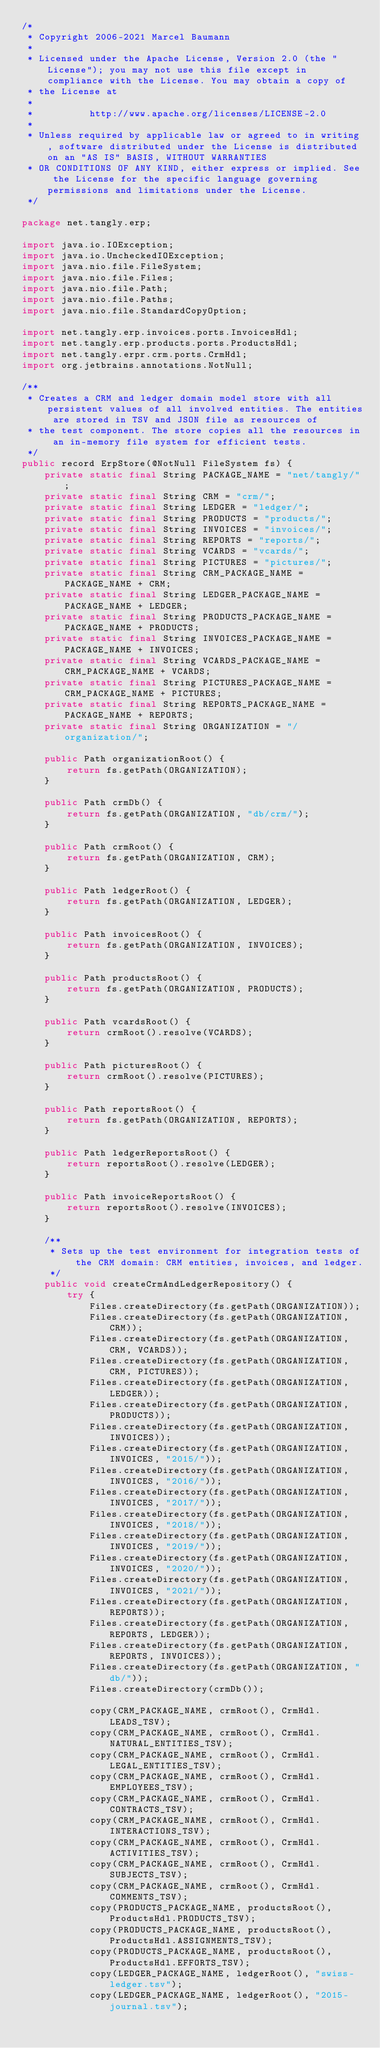<code> <loc_0><loc_0><loc_500><loc_500><_Java_>/*
 * Copyright 2006-2021 Marcel Baumann
 *
 * Licensed under the Apache License, Version 2.0 (the "License"); you may not use this file except in compliance with the License. You may obtain a copy of
 * the License at
 *
 *          http://www.apache.org/licenses/LICENSE-2.0
 *
 * Unless required by applicable law or agreed to in writing, software distributed under the License is distributed on an "AS IS" BASIS, WITHOUT WARRANTIES
 * OR CONDITIONS OF ANY KIND, either express or implied. See the License for the specific language governing permissions and limitations under the License.
 */

package net.tangly.erp;

import java.io.IOException;
import java.io.UncheckedIOException;
import java.nio.file.FileSystem;
import java.nio.file.Files;
import java.nio.file.Path;
import java.nio.file.Paths;
import java.nio.file.StandardCopyOption;

import net.tangly.erp.invoices.ports.InvoicesHdl;
import net.tangly.erp.products.ports.ProductsHdl;
import net.tangly.erpr.crm.ports.CrmHdl;
import org.jetbrains.annotations.NotNull;

/**
 * Creates a CRM and ledger domain model store with all persistent values of all involved entities. The entities are stored in TSV and JSON file as resources of
 * the test component. The store copies all the resources in an in-memory file system for efficient tests.
 */
public record ErpStore(@NotNull FileSystem fs) {
    private static final String PACKAGE_NAME = "net/tangly/";
    private static final String CRM = "crm/";
    private static final String LEDGER = "ledger/";
    private static final String PRODUCTS = "products/";
    private static final String INVOICES = "invoices/";
    private static final String REPORTS = "reports/";
    private static final String VCARDS = "vcards/";
    private static final String PICTURES = "pictures/";
    private static final String CRM_PACKAGE_NAME = PACKAGE_NAME + CRM;
    private static final String LEDGER_PACKAGE_NAME = PACKAGE_NAME + LEDGER;
    private static final String PRODUCTS_PACKAGE_NAME = PACKAGE_NAME + PRODUCTS;
    private static final String INVOICES_PACKAGE_NAME = PACKAGE_NAME + INVOICES;
    private static final String VCARDS_PACKAGE_NAME = CRM_PACKAGE_NAME + VCARDS;
    private static final String PICTURES_PACKAGE_NAME = CRM_PACKAGE_NAME + PICTURES;
    private static final String REPORTS_PACKAGE_NAME = PACKAGE_NAME + REPORTS;
    private static final String ORGANIZATION = "/organization/";

    public Path organizationRoot() {
        return fs.getPath(ORGANIZATION);
    }

    public Path crmDb() {
        return fs.getPath(ORGANIZATION, "db/crm/");
    }

    public Path crmRoot() {
        return fs.getPath(ORGANIZATION, CRM);
    }

    public Path ledgerRoot() {
        return fs.getPath(ORGANIZATION, LEDGER);
    }

    public Path invoicesRoot() {
        return fs.getPath(ORGANIZATION, INVOICES);
    }

    public Path productsRoot() {
        return fs.getPath(ORGANIZATION, PRODUCTS);
    }

    public Path vcardsRoot() {
        return crmRoot().resolve(VCARDS);
    }

    public Path picturesRoot() {
        return crmRoot().resolve(PICTURES);
    }

    public Path reportsRoot() {
        return fs.getPath(ORGANIZATION, REPORTS);
    }

    public Path ledgerReportsRoot() {
        return reportsRoot().resolve(LEDGER);
    }

    public Path invoiceReportsRoot() {
        return reportsRoot().resolve(INVOICES);
    }

    /**
     * Sets up the test environment for integration tests of the CRM domain: CRM entities, invoices, and ledger.
     */
    public void createCrmAndLedgerRepository() {
        try {
            Files.createDirectory(fs.getPath(ORGANIZATION));
            Files.createDirectory(fs.getPath(ORGANIZATION, CRM));
            Files.createDirectory(fs.getPath(ORGANIZATION, CRM, VCARDS));
            Files.createDirectory(fs.getPath(ORGANIZATION, CRM, PICTURES));
            Files.createDirectory(fs.getPath(ORGANIZATION, LEDGER));
            Files.createDirectory(fs.getPath(ORGANIZATION, PRODUCTS));
            Files.createDirectory(fs.getPath(ORGANIZATION, INVOICES));
            Files.createDirectory(fs.getPath(ORGANIZATION, INVOICES, "2015/"));
            Files.createDirectory(fs.getPath(ORGANIZATION, INVOICES, "2016/"));
            Files.createDirectory(fs.getPath(ORGANIZATION, INVOICES, "2017/"));
            Files.createDirectory(fs.getPath(ORGANIZATION, INVOICES, "2018/"));
            Files.createDirectory(fs.getPath(ORGANIZATION, INVOICES, "2019/"));
            Files.createDirectory(fs.getPath(ORGANIZATION, INVOICES, "2020/"));
            Files.createDirectory(fs.getPath(ORGANIZATION, INVOICES, "2021/"));
            Files.createDirectory(fs.getPath(ORGANIZATION, REPORTS));
            Files.createDirectory(fs.getPath(ORGANIZATION, REPORTS, LEDGER));
            Files.createDirectory(fs.getPath(ORGANIZATION, REPORTS, INVOICES));
            Files.createDirectory(fs.getPath(ORGANIZATION, "db/"));
            Files.createDirectory(crmDb());

            copy(CRM_PACKAGE_NAME, crmRoot(), CrmHdl.LEADS_TSV);
            copy(CRM_PACKAGE_NAME, crmRoot(), CrmHdl.NATURAL_ENTITIES_TSV);
            copy(CRM_PACKAGE_NAME, crmRoot(), CrmHdl.LEGAL_ENTITIES_TSV);
            copy(CRM_PACKAGE_NAME, crmRoot(), CrmHdl.EMPLOYEES_TSV);
            copy(CRM_PACKAGE_NAME, crmRoot(), CrmHdl.CONTRACTS_TSV);
            copy(CRM_PACKAGE_NAME, crmRoot(), CrmHdl.INTERACTIONS_TSV);
            copy(CRM_PACKAGE_NAME, crmRoot(), CrmHdl.ACTIVITIES_TSV);
            copy(CRM_PACKAGE_NAME, crmRoot(), CrmHdl.SUBJECTS_TSV);
            copy(CRM_PACKAGE_NAME, crmRoot(), CrmHdl.COMMENTS_TSV);
            copy(PRODUCTS_PACKAGE_NAME, productsRoot(), ProductsHdl.PRODUCTS_TSV);
            copy(PRODUCTS_PACKAGE_NAME, productsRoot(), ProductsHdl.ASSIGNMENTS_TSV);
            copy(PRODUCTS_PACKAGE_NAME, productsRoot(), ProductsHdl.EFFORTS_TSV);
            copy(LEDGER_PACKAGE_NAME, ledgerRoot(), "swiss-ledger.tsv");
            copy(LEDGER_PACKAGE_NAME, ledgerRoot(), "2015-journal.tsv");</code> 